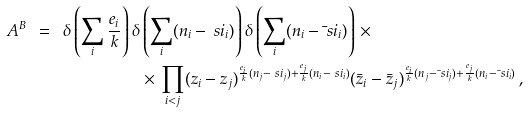<formula> <loc_0><loc_0><loc_500><loc_500>A ^ { B } \ = \ \delta \left ( \sum _ { i } \frac { e _ { i } } { k } \right ) \delta & \left ( \sum _ { i } ( n _ { i } - \ s i _ { i } ) \right ) \delta \left ( \sum _ { i } ( n _ { i } - \bar { \ } s i _ { i } ) \right ) \, \times \\ & \times \, \prod _ { i < j } ( z _ { i } - z _ { j } ) ^ { \frac { e _ { i } } { k } ( n _ { j } - \ s i _ { j } ) + \frac { e _ { j } } { k } ( n _ { i } - \ s i _ { i } ) } ( \bar { z } _ { i } - \bar { z } _ { j } ) ^ { \frac { e _ { i } } { k } ( n _ { j } - \bar { \ } s i _ { j } ) + \frac { e _ { j } } { k } ( n _ { i } - \bar { \ } s i _ { i } ) } \, , \\</formula> 